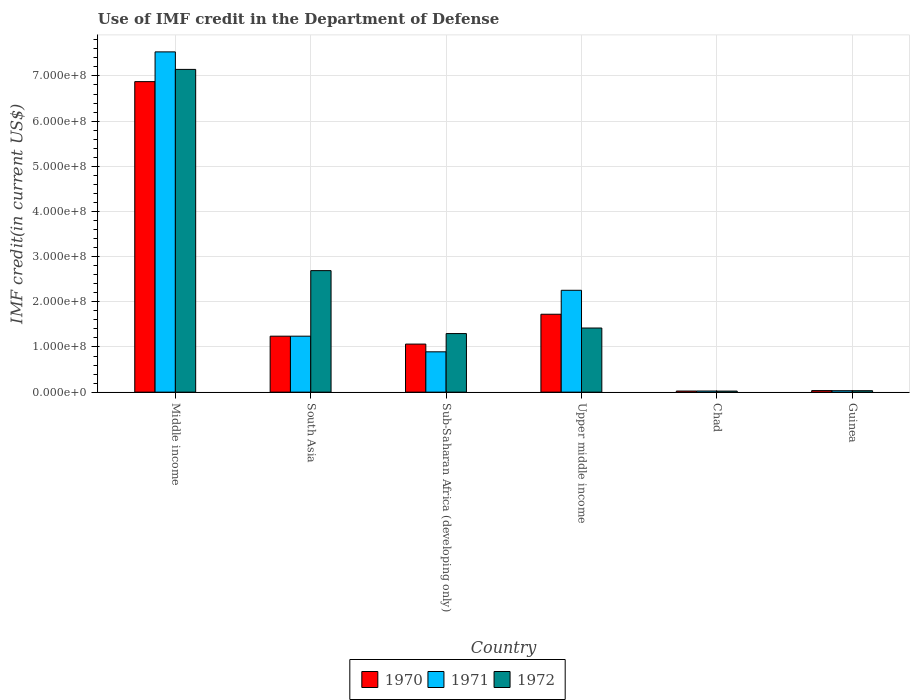How many different coloured bars are there?
Offer a terse response. 3. How many groups of bars are there?
Ensure brevity in your answer.  6. Are the number of bars on each tick of the X-axis equal?
Offer a terse response. Yes. What is the label of the 6th group of bars from the left?
Your answer should be very brief. Guinea. What is the IMF credit in the Department of Defense in 1972 in Middle income?
Make the answer very short. 7.14e+08. Across all countries, what is the maximum IMF credit in the Department of Defense in 1972?
Give a very brief answer. 7.14e+08. Across all countries, what is the minimum IMF credit in the Department of Defense in 1972?
Provide a short and direct response. 2.37e+06. In which country was the IMF credit in the Department of Defense in 1971 minimum?
Your answer should be very brief. Chad. What is the total IMF credit in the Department of Defense in 1971 in the graph?
Offer a terse response. 1.20e+09. What is the difference between the IMF credit in the Department of Defense in 1972 in Guinea and that in South Asia?
Provide a short and direct response. -2.66e+08. What is the difference between the IMF credit in the Department of Defense in 1971 in Upper middle income and the IMF credit in the Department of Defense in 1972 in Chad?
Your answer should be very brief. 2.23e+08. What is the average IMF credit in the Department of Defense in 1970 per country?
Your answer should be very brief. 1.83e+08. In how many countries, is the IMF credit in the Department of Defense in 1970 greater than 140000000 US$?
Offer a terse response. 2. What is the ratio of the IMF credit in the Department of Defense in 1972 in Guinea to that in Upper middle income?
Make the answer very short. 0.02. Is the difference between the IMF credit in the Department of Defense in 1972 in South Asia and Sub-Saharan Africa (developing only) greater than the difference between the IMF credit in the Department of Defense in 1971 in South Asia and Sub-Saharan Africa (developing only)?
Offer a very short reply. Yes. What is the difference between the highest and the second highest IMF credit in the Department of Defense in 1971?
Provide a succinct answer. -5.28e+08. What is the difference between the highest and the lowest IMF credit in the Department of Defense in 1970?
Offer a very short reply. 6.85e+08. Are all the bars in the graph horizontal?
Keep it short and to the point. No. How are the legend labels stacked?
Your response must be concise. Horizontal. What is the title of the graph?
Keep it short and to the point. Use of IMF credit in the Department of Defense. What is the label or title of the Y-axis?
Offer a terse response. IMF credit(in current US$). What is the IMF credit(in current US$) of 1970 in Middle income?
Your answer should be compact. 6.87e+08. What is the IMF credit(in current US$) of 1971 in Middle income?
Provide a short and direct response. 7.53e+08. What is the IMF credit(in current US$) of 1972 in Middle income?
Make the answer very short. 7.14e+08. What is the IMF credit(in current US$) of 1970 in South Asia?
Ensure brevity in your answer.  1.24e+08. What is the IMF credit(in current US$) in 1971 in South Asia?
Keep it short and to the point. 1.24e+08. What is the IMF credit(in current US$) in 1972 in South Asia?
Provide a short and direct response. 2.69e+08. What is the IMF credit(in current US$) of 1970 in Sub-Saharan Africa (developing only)?
Make the answer very short. 1.06e+08. What is the IMF credit(in current US$) of 1971 in Sub-Saharan Africa (developing only)?
Give a very brief answer. 8.93e+07. What is the IMF credit(in current US$) of 1972 in Sub-Saharan Africa (developing only)?
Your response must be concise. 1.30e+08. What is the IMF credit(in current US$) of 1970 in Upper middle income?
Make the answer very short. 1.72e+08. What is the IMF credit(in current US$) of 1971 in Upper middle income?
Your answer should be very brief. 2.25e+08. What is the IMF credit(in current US$) in 1972 in Upper middle income?
Offer a very short reply. 1.42e+08. What is the IMF credit(in current US$) of 1970 in Chad?
Offer a very short reply. 2.47e+06. What is the IMF credit(in current US$) of 1971 in Chad?
Your response must be concise. 2.52e+06. What is the IMF credit(in current US$) in 1972 in Chad?
Your answer should be compact. 2.37e+06. What is the IMF credit(in current US$) in 1970 in Guinea?
Your response must be concise. 3.45e+06. What is the IMF credit(in current US$) of 1971 in Guinea?
Offer a terse response. 3.20e+06. What is the IMF credit(in current US$) in 1972 in Guinea?
Provide a short and direct response. 3.20e+06. Across all countries, what is the maximum IMF credit(in current US$) of 1970?
Provide a succinct answer. 6.87e+08. Across all countries, what is the maximum IMF credit(in current US$) of 1971?
Your answer should be very brief. 7.53e+08. Across all countries, what is the maximum IMF credit(in current US$) in 1972?
Provide a short and direct response. 7.14e+08. Across all countries, what is the minimum IMF credit(in current US$) in 1970?
Offer a very short reply. 2.47e+06. Across all countries, what is the minimum IMF credit(in current US$) in 1971?
Give a very brief answer. 2.52e+06. Across all countries, what is the minimum IMF credit(in current US$) of 1972?
Provide a succinct answer. 2.37e+06. What is the total IMF credit(in current US$) in 1970 in the graph?
Your answer should be compact. 1.10e+09. What is the total IMF credit(in current US$) of 1971 in the graph?
Your response must be concise. 1.20e+09. What is the total IMF credit(in current US$) in 1972 in the graph?
Offer a very short reply. 1.26e+09. What is the difference between the IMF credit(in current US$) of 1970 in Middle income and that in South Asia?
Ensure brevity in your answer.  5.64e+08. What is the difference between the IMF credit(in current US$) of 1971 in Middle income and that in South Asia?
Your response must be concise. 6.29e+08. What is the difference between the IMF credit(in current US$) of 1972 in Middle income and that in South Asia?
Provide a short and direct response. 4.45e+08. What is the difference between the IMF credit(in current US$) of 1970 in Middle income and that in Sub-Saharan Africa (developing only)?
Give a very brief answer. 5.81e+08. What is the difference between the IMF credit(in current US$) of 1971 in Middle income and that in Sub-Saharan Africa (developing only)?
Your response must be concise. 6.64e+08. What is the difference between the IMF credit(in current US$) of 1972 in Middle income and that in Sub-Saharan Africa (developing only)?
Keep it short and to the point. 5.85e+08. What is the difference between the IMF credit(in current US$) of 1970 in Middle income and that in Upper middle income?
Keep it short and to the point. 5.15e+08. What is the difference between the IMF credit(in current US$) of 1971 in Middle income and that in Upper middle income?
Offer a very short reply. 5.28e+08. What is the difference between the IMF credit(in current US$) in 1972 in Middle income and that in Upper middle income?
Provide a short and direct response. 5.73e+08. What is the difference between the IMF credit(in current US$) in 1970 in Middle income and that in Chad?
Your response must be concise. 6.85e+08. What is the difference between the IMF credit(in current US$) in 1971 in Middle income and that in Chad?
Ensure brevity in your answer.  7.51e+08. What is the difference between the IMF credit(in current US$) in 1972 in Middle income and that in Chad?
Your answer should be very brief. 7.12e+08. What is the difference between the IMF credit(in current US$) of 1970 in Middle income and that in Guinea?
Keep it short and to the point. 6.84e+08. What is the difference between the IMF credit(in current US$) of 1971 in Middle income and that in Guinea?
Ensure brevity in your answer.  7.50e+08. What is the difference between the IMF credit(in current US$) in 1972 in Middle income and that in Guinea?
Your answer should be very brief. 7.11e+08. What is the difference between the IMF credit(in current US$) of 1970 in South Asia and that in Sub-Saharan Africa (developing only)?
Provide a short and direct response. 1.75e+07. What is the difference between the IMF credit(in current US$) in 1971 in South Asia and that in Sub-Saharan Africa (developing only)?
Give a very brief answer. 3.46e+07. What is the difference between the IMF credit(in current US$) of 1972 in South Asia and that in Sub-Saharan Africa (developing only)?
Offer a terse response. 1.39e+08. What is the difference between the IMF credit(in current US$) of 1970 in South Asia and that in Upper middle income?
Offer a very short reply. -4.86e+07. What is the difference between the IMF credit(in current US$) of 1971 in South Asia and that in Upper middle income?
Offer a terse response. -1.02e+08. What is the difference between the IMF credit(in current US$) of 1972 in South Asia and that in Upper middle income?
Make the answer very short. 1.27e+08. What is the difference between the IMF credit(in current US$) of 1970 in South Asia and that in Chad?
Keep it short and to the point. 1.21e+08. What is the difference between the IMF credit(in current US$) in 1971 in South Asia and that in Chad?
Your response must be concise. 1.21e+08. What is the difference between the IMF credit(in current US$) in 1972 in South Asia and that in Chad?
Keep it short and to the point. 2.67e+08. What is the difference between the IMF credit(in current US$) of 1970 in South Asia and that in Guinea?
Provide a succinct answer. 1.20e+08. What is the difference between the IMF credit(in current US$) of 1971 in South Asia and that in Guinea?
Offer a very short reply. 1.21e+08. What is the difference between the IMF credit(in current US$) of 1972 in South Asia and that in Guinea?
Provide a short and direct response. 2.66e+08. What is the difference between the IMF credit(in current US$) of 1970 in Sub-Saharan Africa (developing only) and that in Upper middle income?
Your answer should be compact. -6.61e+07. What is the difference between the IMF credit(in current US$) in 1971 in Sub-Saharan Africa (developing only) and that in Upper middle income?
Keep it short and to the point. -1.36e+08. What is the difference between the IMF credit(in current US$) in 1972 in Sub-Saharan Africa (developing only) and that in Upper middle income?
Offer a terse response. -1.23e+07. What is the difference between the IMF credit(in current US$) of 1970 in Sub-Saharan Africa (developing only) and that in Chad?
Your answer should be compact. 1.04e+08. What is the difference between the IMF credit(in current US$) of 1971 in Sub-Saharan Africa (developing only) and that in Chad?
Your answer should be compact. 8.68e+07. What is the difference between the IMF credit(in current US$) in 1972 in Sub-Saharan Africa (developing only) and that in Chad?
Make the answer very short. 1.27e+08. What is the difference between the IMF credit(in current US$) of 1970 in Sub-Saharan Africa (developing only) and that in Guinea?
Your response must be concise. 1.03e+08. What is the difference between the IMF credit(in current US$) in 1971 in Sub-Saharan Africa (developing only) and that in Guinea?
Offer a very short reply. 8.61e+07. What is the difference between the IMF credit(in current US$) of 1972 in Sub-Saharan Africa (developing only) and that in Guinea?
Make the answer very short. 1.26e+08. What is the difference between the IMF credit(in current US$) in 1970 in Upper middle income and that in Chad?
Offer a terse response. 1.70e+08. What is the difference between the IMF credit(in current US$) of 1971 in Upper middle income and that in Chad?
Your answer should be very brief. 2.23e+08. What is the difference between the IMF credit(in current US$) of 1972 in Upper middle income and that in Chad?
Offer a terse response. 1.40e+08. What is the difference between the IMF credit(in current US$) in 1970 in Upper middle income and that in Guinea?
Give a very brief answer. 1.69e+08. What is the difference between the IMF credit(in current US$) in 1971 in Upper middle income and that in Guinea?
Offer a terse response. 2.22e+08. What is the difference between the IMF credit(in current US$) of 1972 in Upper middle income and that in Guinea?
Your answer should be compact. 1.39e+08. What is the difference between the IMF credit(in current US$) in 1970 in Chad and that in Guinea?
Offer a terse response. -9.80e+05. What is the difference between the IMF credit(in current US$) of 1971 in Chad and that in Guinea?
Ensure brevity in your answer.  -6.84e+05. What is the difference between the IMF credit(in current US$) in 1972 in Chad and that in Guinea?
Your response must be concise. -8.36e+05. What is the difference between the IMF credit(in current US$) in 1970 in Middle income and the IMF credit(in current US$) in 1971 in South Asia?
Provide a short and direct response. 5.64e+08. What is the difference between the IMF credit(in current US$) of 1970 in Middle income and the IMF credit(in current US$) of 1972 in South Asia?
Offer a very short reply. 4.18e+08. What is the difference between the IMF credit(in current US$) in 1971 in Middle income and the IMF credit(in current US$) in 1972 in South Asia?
Provide a short and direct response. 4.84e+08. What is the difference between the IMF credit(in current US$) in 1970 in Middle income and the IMF credit(in current US$) in 1971 in Sub-Saharan Africa (developing only)?
Make the answer very short. 5.98e+08. What is the difference between the IMF credit(in current US$) in 1970 in Middle income and the IMF credit(in current US$) in 1972 in Sub-Saharan Africa (developing only)?
Provide a short and direct response. 5.58e+08. What is the difference between the IMF credit(in current US$) of 1971 in Middle income and the IMF credit(in current US$) of 1972 in Sub-Saharan Africa (developing only)?
Ensure brevity in your answer.  6.24e+08. What is the difference between the IMF credit(in current US$) of 1970 in Middle income and the IMF credit(in current US$) of 1971 in Upper middle income?
Give a very brief answer. 4.62e+08. What is the difference between the IMF credit(in current US$) in 1970 in Middle income and the IMF credit(in current US$) in 1972 in Upper middle income?
Give a very brief answer. 5.45e+08. What is the difference between the IMF credit(in current US$) of 1971 in Middle income and the IMF credit(in current US$) of 1972 in Upper middle income?
Provide a short and direct response. 6.11e+08. What is the difference between the IMF credit(in current US$) in 1970 in Middle income and the IMF credit(in current US$) in 1971 in Chad?
Give a very brief answer. 6.85e+08. What is the difference between the IMF credit(in current US$) of 1970 in Middle income and the IMF credit(in current US$) of 1972 in Chad?
Give a very brief answer. 6.85e+08. What is the difference between the IMF credit(in current US$) in 1971 in Middle income and the IMF credit(in current US$) in 1972 in Chad?
Your answer should be very brief. 7.51e+08. What is the difference between the IMF credit(in current US$) of 1970 in Middle income and the IMF credit(in current US$) of 1971 in Guinea?
Your answer should be compact. 6.84e+08. What is the difference between the IMF credit(in current US$) in 1970 in Middle income and the IMF credit(in current US$) in 1972 in Guinea?
Make the answer very short. 6.84e+08. What is the difference between the IMF credit(in current US$) of 1971 in Middle income and the IMF credit(in current US$) of 1972 in Guinea?
Your answer should be compact. 7.50e+08. What is the difference between the IMF credit(in current US$) in 1970 in South Asia and the IMF credit(in current US$) in 1971 in Sub-Saharan Africa (developing only)?
Your answer should be compact. 3.46e+07. What is the difference between the IMF credit(in current US$) of 1970 in South Asia and the IMF credit(in current US$) of 1972 in Sub-Saharan Africa (developing only)?
Make the answer very short. -5.79e+06. What is the difference between the IMF credit(in current US$) in 1971 in South Asia and the IMF credit(in current US$) in 1972 in Sub-Saharan Africa (developing only)?
Ensure brevity in your answer.  -5.79e+06. What is the difference between the IMF credit(in current US$) of 1970 in South Asia and the IMF credit(in current US$) of 1971 in Upper middle income?
Make the answer very short. -1.02e+08. What is the difference between the IMF credit(in current US$) of 1970 in South Asia and the IMF credit(in current US$) of 1972 in Upper middle income?
Your answer should be compact. -1.80e+07. What is the difference between the IMF credit(in current US$) of 1971 in South Asia and the IMF credit(in current US$) of 1972 in Upper middle income?
Provide a succinct answer. -1.80e+07. What is the difference between the IMF credit(in current US$) in 1970 in South Asia and the IMF credit(in current US$) in 1971 in Chad?
Give a very brief answer. 1.21e+08. What is the difference between the IMF credit(in current US$) of 1970 in South Asia and the IMF credit(in current US$) of 1972 in Chad?
Give a very brief answer. 1.22e+08. What is the difference between the IMF credit(in current US$) of 1971 in South Asia and the IMF credit(in current US$) of 1972 in Chad?
Offer a very short reply. 1.22e+08. What is the difference between the IMF credit(in current US$) of 1970 in South Asia and the IMF credit(in current US$) of 1971 in Guinea?
Offer a terse response. 1.21e+08. What is the difference between the IMF credit(in current US$) of 1970 in South Asia and the IMF credit(in current US$) of 1972 in Guinea?
Offer a terse response. 1.21e+08. What is the difference between the IMF credit(in current US$) in 1971 in South Asia and the IMF credit(in current US$) in 1972 in Guinea?
Keep it short and to the point. 1.21e+08. What is the difference between the IMF credit(in current US$) of 1970 in Sub-Saharan Africa (developing only) and the IMF credit(in current US$) of 1971 in Upper middle income?
Ensure brevity in your answer.  -1.19e+08. What is the difference between the IMF credit(in current US$) in 1970 in Sub-Saharan Africa (developing only) and the IMF credit(in current US$) in 1972 in Upper middle income?
Your answer should be compact. -3.56e+07. What is the difference between the IMF credit(in current US$) in 1971 in Sub-Saharan Africa (developing only) and the IMF credit(in current US$) in 1972 in Upper middle income?
Ensure brevity in your answer.  -5.27e+07. What is the difference between the IMF credit(in current US$) in 1970 in Sub-Saharan Africa (developing only) and the IMF credit(in current US$) in 1971 in Chad?
Your answer should be compact. 1.04e+08. What is the difference between the IMF credit(in current US$) of 1970 in Sub-Saharan Africa (developing only) and the IMF credit(in current US$) of 1972 in Chad?
Your response must be concise. 1.04e+08. What is the difference between the IMF credit(in current US$) of 1971 in Sub-Saharan Africa (developing only) and the IMF credit(in current US$) of 1972 in Chad?
Ensure brevity in your answer.  8.69e+07. What is the difference between the IMF credit(in current US$) of 1970 in Sub-Saharan Africa (developing only) and the IMF credit(in current US$) of 1971 in Guinea?
Provide a succinct answer. 1.03e+08. What is the difference between the IMF credit(in current US$) in 1970 in Sub-Saharan Africa (developing only) and the IMF credit(in current US$) in 1972 in Guinea?
Offer a terse response. 1.03e+08. What is the difference between the IMF credit(in current US$) of 1971 in Sub-Saharan Africa (developing only) and the IMF credit(in current US$) of 1972 in Guinea?
Offer a very short reply. 8.61e+07. What is the difference between the IMF credit(in current US$) in 1970 in Upper middle income and the IMF credit(in current US$) in 1971 in Chad?
Give a very brief answer. 1.70e+08. What is the difference between the IMF credit(in current US$) of 1970 in Upper middle income and the IMF credit(in current US$) of 1972 in Chad?
Your answer should be very brief. 1.70e+08. What is the difference between the IMF credit(in current US$) of 1971 in Upper middle income and the IMF credit(in current US$) of 1972 in Chad?
Your answer should be compact. 2.23e+08. What is the difference between the IMF credit(in current US$) of 1970 in Upper middle income and the IMF credit(in current US$) of 1971 in Guinea?
Make the answer very short. 1.69e+08. What is the difference between the IMF credit(in current US$) of 1970 in Upper middle income and the IMF credit(in current US$) of 1972 in Guinea?
Your answer should be compact. 1.69e+08. What is the difference between the IMF credit(in current US$) in 1971 in Upper middle income and the IMF credit(in current US$) in 1972 in Guinea?
Your response must be concise. 2.22e+08. What is the difference between the IMF credit(in current US$) of 1970 in Chad and the IMF credit(in current US$) of 1971 in Guinea?
Offer a terse response. -7.33e+05. What is the difference between the IMF credit(in current US$) in 1970 in Chad and the IMF credit(in current US$) in 1972 in Guinea?
Your response must be concise. -7.33e+05. What is the difference between the IMF credit(in current US$) of 1971 in Chad and the IMF credit(in current US$) of 1972 in Guinea?
Provide a succinct answer. -6.84e+05. What is the average IMF credit(in current US$) of 1970 per country?
Offer a very short reply. 1.83e+08. What is the average IMF credit(in current US$) in 1971 per country?
Your response must be concise. 2.00e+08. What is the average IMF credit(in current US$) of 1972 per country?
Provide a succinct answer. 2.10e+08. What is the difference between the IMF credit(in current US$) in 1970 and IMF credit(in current US$) in 1971 in Middle income?
Keep it short and to the point. -6.58e+07. What is the difference between the IMF credit(in current US$) in 1970 and IMF credit(in current US$) in 1972 in Middle income?
Provide a succinct answer. -2.71e+07. What is the difference between the IMF credit(in current US$) in 1971 and IMF credit(in current US$) in 1972 in Middle income?
Provide a short and direct response. 3.88e+07. What is the difference between the IMF credit(in current US$) in 1970 and IMF credit(in current US$) in 1972 in South Asia?
Give a very brief answer. -1.45e+08. What is the difference between the IMF credit(in current US$) of 1971 and IMF credit(in current US$) of 1972 in South Asia?
Offer a very short reply. -1.45e+08. What is the difference between the IMF credit(in current US$) of 1970 and IMF credit(in current US$) of 1971 in Sub-Saharan Africa (developing only)?
Keep it short and to the point. 1.71e+07. What is the difference between the IMF credit(in current US$) in 1970 and IMF credit(in current US$) in 1972 in Sub-Saharan Africa (developing only)?
Provide a short and direct response. -2.33e+07. What is the difference between the IMF credit(in current US$) of 1971 and IMF credit(in current US$) of 1972 in Sub-Saharan Africa (developing only)?
Your answer should be very brief. -4.04e+07. What is the difference between the IMF credit(in current US$) in 1970 and IMF credit(in current US$) in 1971 in Upper middle income?
Your response must be concise. -5.30e+07. What is the difference between the IMF credit(in current US$) in 1970 and IMF credit(in current US$) in 1972 in Upper middle income?
Ensure brevity in your answer.  3.05e+07. What is the difference between the IMF credit(in current US$) in 1971 and IMF credit(in current US$) in 1972 in Upper middle income?
Ensure brevity in your answer.  8.35e+07. What is the difference between the IMF credit(in current US$) of 1970 and IMF credit(in current US$) of 1971 in Chad?
Keep it short and to the point. -4.90e+04. What is the difference between the IMF credit(in current US$) in 1970 and IMF credit(in current US$) in 1972 in Chad?
Provide a short and direct response. 1.03e+05. What is the difference between the IMF credit(in current US$) in 1971 and IMF credit(in current US$) in 1972 in Chad?
Your answer should be compact. 1.52e+05. What is the difference between the IMF credit(in current US$) of 1970 and IMF credit(in current US$) of 1971 in Guinea?
Give a very brief answer. 2.47e+05. What is the difference between the IMF credit(in current US$) of 1970 and IMF credit(in current US$) of 1972 in Guinea?
Make the answer very short. 2.47e+05. What is the difference between the IMF credit(in current US$) in 1971 and IMF credit(in current US$) in 1972 in Guinea?
Give a very brief answer. 0. What is the ratio of the IMF credit(in current US$) in 1970 in Middle income to that in South Asia?
Keep it short and to the point. 5.55. What is the ratio of the IMF credit(in current US$) in 1971 in Middle income to that in South Asia?
Give a very brief answer. 6.08. What is the ratio of the IMF credit(in current US$) of 1972 in Middle income to that in South Asia?
Offer a terse response. 2.66. What is the ratio of the IMF credit(in current US$) of 1970 in Middle income to that in Sub-Saharan Africa (developing only)?
Provide a short and direct response. 6.46. What is the ratio of the IMF credit(in current US$) in 1971 in Middle income to that in Sub-Saharan Africa (developing only)?
Provide a short and direct response. 8.44. What is the ratio of the IMF credit(in current US$) in 1972 in Middle income to that in Sub-Saharan Africa (developing only)?
Make the answer very short. 5.51. What is the ratio of the IMF credit(in current US$) of 1970 in Middle income to that in Upper middle income?
Your answer should be very brief. 3.99. What is the ratio of the IMF credit(in current US$) in 1971 in Middle income to that in Upper middle income?
Offer a very short reply. 3.34. What is the ratio of the IMF credit(in current US$) of 1972 in Middle income to that in Upper middle income?
Ensure brevity in your answer.  5.03. What is the ratio of the IMF credit(in current US$) of 1970 in Middle income to that in Chad?
Offer a very short reply. 278.3. What is the ratio of the IMF credit(in current US$) of 1971 in Middle income to that in Chad?
Make the answer very short. 299.03. What is the ratio of the IMF credit(in current US$) in 1972 in Middle income to that in Chad?
Provide a succinct answer. 301.85. What is the ratio of the IMF credit(in current US$) of 1970 in Middle income to that in Guinea?
Give a very brief answer. 199.25. What is the ratio of the IMF credit(in current US$) of 1971 in Middle income to that in Guinea?
Your answer should be very brief. 235.17. What is the ratio of the IMF credit(in current US$) in 1972 in Middle income to that in Guinea?
Give a very brief answer. 223.06. What is the ratio of the IMF credit(in current US$) in 1970 in South Asia to that in Sub-Saharan Africa (developing only)?
Give a very brief answer. 1.16. What is the ratio of the IMF credit(in current US$) of 1971 in South Asia to that in Sub-Saharan Africa (developing only)?
Make the answer very short. 1.39. What is the ratio of the IMF credit(in current US$) in 1972 in South Asia to that in Sub-Saharan Africa (developing only)?
Your answer should be very brief. 2.07. What is the ratio of the IMF credit(in current US$) of 1970 in South Asia to that in Upper middle income?
Make the answer very short. 0.72. What is the ratio of the IMF credit(in current US$) of 1971 in South Asia to that in Upper middle income?
Your answer should be compact. 0.55. What is the ratio of the IMF credit(in current US$) in 1972 in South Asia to that in Upper middle income?
Your response must be concise. 1.9. What is the ratio of the IMF credit(in current US$) of 1970 in South Asia to that in Chad?
Your response must be concise. 50.16. What is the ratio of the IMF credit(in current US$) of 1971 in South Asia to that in Chad?
Make the answer very short. 49.19. What is the ratio of the IMF credit(in current US$) of 1972 in South Asia to that in Chad?
Offer a very short reply. 113.64. What is the ratio of the IMF credit(in current US$) in 1970 in South Asia to that in Guinea?
Your answer should be compact. 35.91. What is the ratio of the IMF credit(in current US$) in 1971 in South Asia to that in Guinea?
Provide a succinct answer. 38.68. What is the ratio of the IMF credit(in current US$) of 1972 in South Asia to that in Guinea?
Ensure brevity in your answer.  83.98. What is the ratio of the IMF credit(in current US$) of 1970 in Sub-Saharan Africa (developing only) to that in Upper middle income?
Offer a terse response. 0.62. What is the ratio of the IMF credit(in current US$) of 1971 in Sub-Saharan Africa (developing only) to that in Upper middle income?
Keep it short and to the point. 0.4. What is the ratio of the IMF credit(in current US$) in 1972 in Sub-Saharan Africa (developing only) to that in Upper middle income?
Offer a very short reply. 0.91. What is the ratio of the IMF credit(in current US$) of 1970 in Sub-Saharan Africa (developing only) to that in Chad?
Your answer should be compact. 43.07. What is the ratio of the IMF credit(in current US$) of 1971 in Sub-Saharan Africa (developing only) to that in Chad?
Your answer should be very brief. 35.45. What is the ratio of the IMF credit(in current US$) of 1972 in Sub-Saharan Africa (developing only) to that in Chad?
Ensure brevity in your answer.  54.79. What is the ratio of the IMF credit(in current US$) in 1970 in Sub-Saharan Africa (developing only) to that in Guinea?
Give a very brief answer. 30.84. What is the ratio of the IMF credit(in current US$) in 1971 in Sub-Saharan Africa (developing only) to that in Guinea?
Your response must be concise. 27.88. What is the ratio of the IMF credit(in current US$) in 1972 in Sub-Saharan Africa (developing only) to that in Guinea?
Keep it short and to the point. 40.49. What is the ratio of the IMF credit(in current US$) of 1970 in Upper middle income to that in Chad?
Provide a short and direct response. 69.82. What is the ratio of the IMF credit(in current US$) in 1971 in Upper middle income to that in Chad?
Provide a short and direct response. 89.51. What is the ratio of the IMF credit(in current US$) in 1972 in Upper middle income to that in Chad?
Provide a succinct answer. 59.97. What is the ratio of the IMF credit(in current US$) of 1970 in Upper middle income to that in Guinea?
Keep it short and to the point. 49.99. What is the ratio of the IMF credit(in current US$) of 1971 in Upper middle income to that in Guinea?
Ensure brevity in your answer.  70.4. What is the ratio of the IMF credit(in current US$) of 1972 in Upper middle income to that in Guinea?
Provide a succinct answer. 44.32. What is the ratio of the IMF credit(in current US$) in 1970 in Chad to that in Guinea?
Your answer should be compact. 0.72. What is the ratio of the IMF credit(in current US$) in 1971 in Chad to that in Guinea?
Provide a short and direct response. 0.79. What is the ratio of the IMF credit(in current US$) in 1972 in Chad to that in Guinea?
Your response must be concise. 0.74. What is the difference between the highest and the second highest IMF credit(in current US$) of 1970?
Offer a very short reply. 5.15e+08. What is the difference between the highest and the second highest IMF credit(in current US$) in 1971?
Offer a terse response. 5.28e+08. What is the difference between the highest and the second highest IMF credit(in current US$) in 1972?
Offer a very short reply. 4.45e+08. What is the difference between the highest and the lowest IMF credit(in current US$) of 1970?
Offer a very short reply. 6.85e+08. What is the difference between the highest and the lowest IMF credit(in current US$) in 1971?
Provide a succinct answer. 7.51e+08. What is the difference between the highest and the lowest IMF credit(in current US$) in 1972?
Make the answer very short. 7.12e+08. 